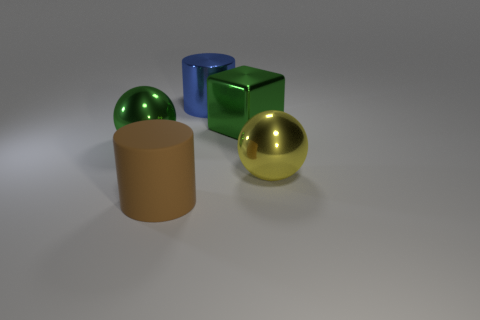Add 4 large green spheres. How many objects exist? 9 Subtract all cylinders. How many objects are left? 3 Subtract all green things. Subtract all green shiny blocks. How many objects are left? 2 Add 5 big cylinders. How many big cylinders are left? 7 Add 3 big brown metal things. How many big brown metal things exist? 3 Subtract 0 red spheres. How many objects are left? 5 